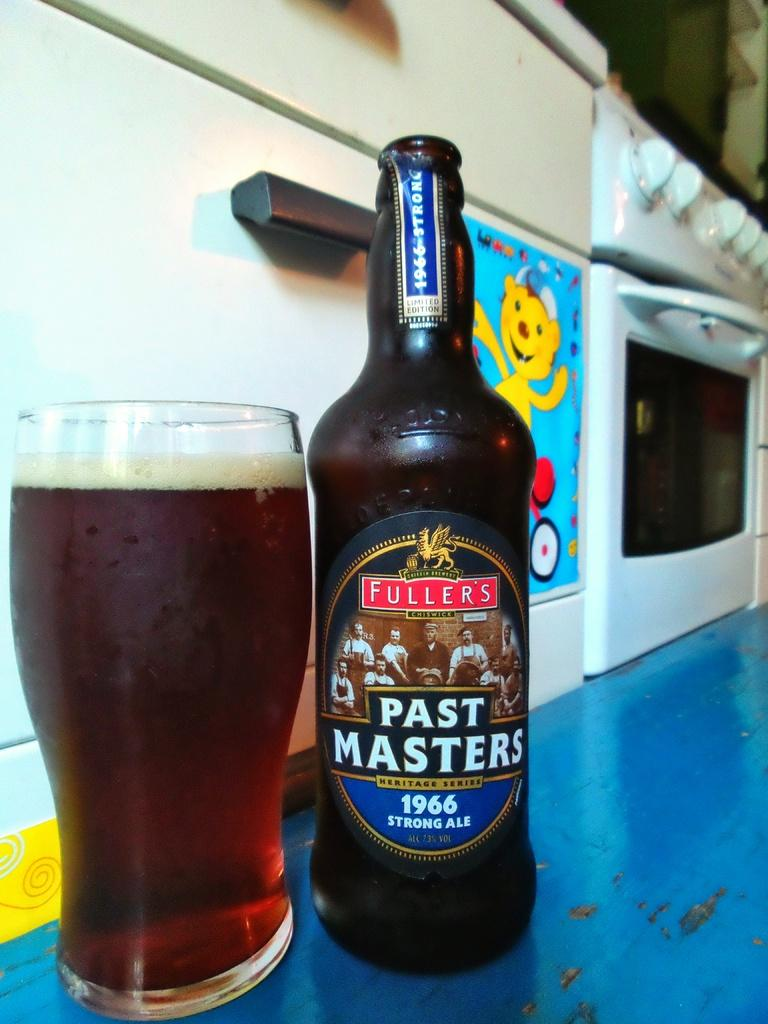What object can be seen in the image that might be used for holding or storing a liquid? There is a bottle in the image. What other object is present in the image that might also be used for holding a liquid? There is a glass with liquid in the image. What type of appliance can be seen in the image that is typically used for cooking or baking? There are ovens in the image. What type of quartz can be seen in the image? There is no quartz present in the image. What type of teeth can be seen in the image? There are no teeth present in the image. 